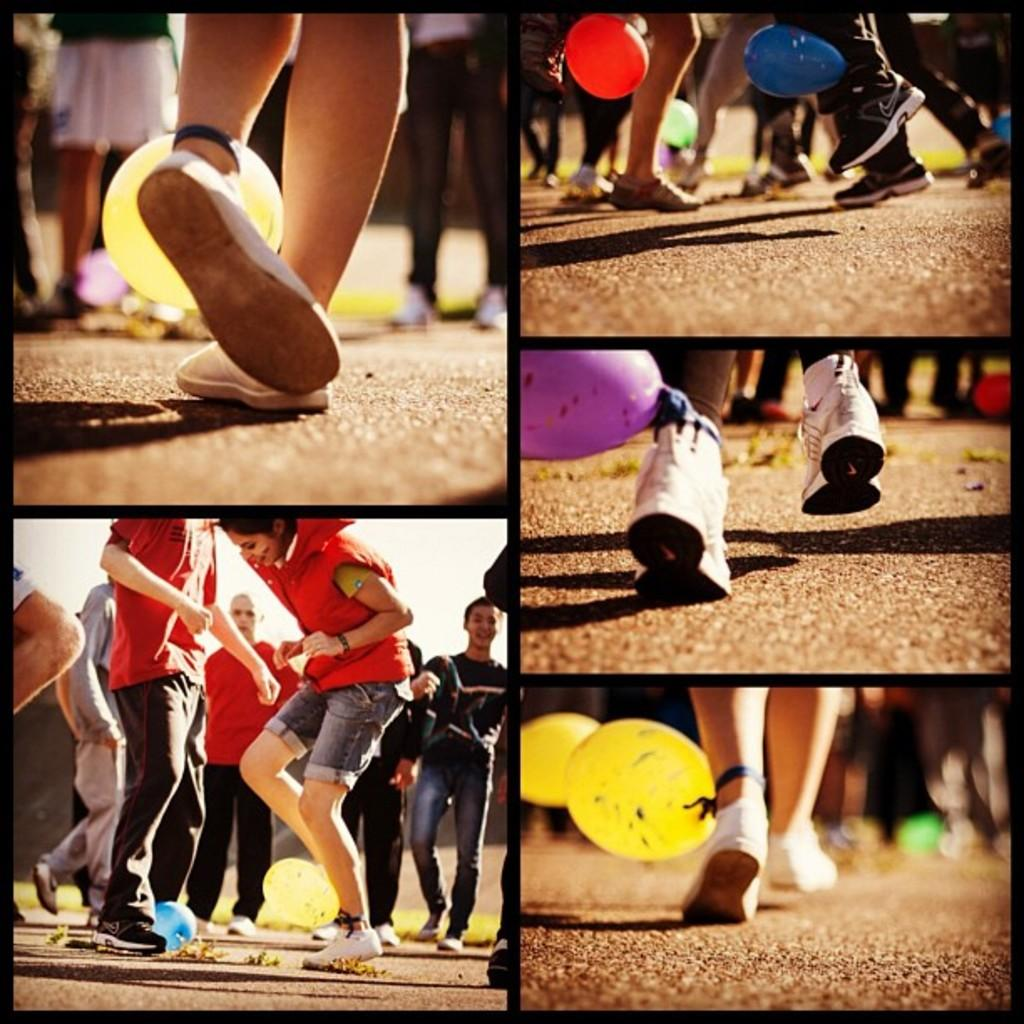What type of artwork is the image? The image is a collage. What activity can be seen in the collage? People are playing in the collage. What body parts of the people are visible in the collage? Legs of people are visible in the collage. What type of care can be seen being provided to the pigs in the image? There are no pigs present in the image, so no care can be seen being provided to them. 